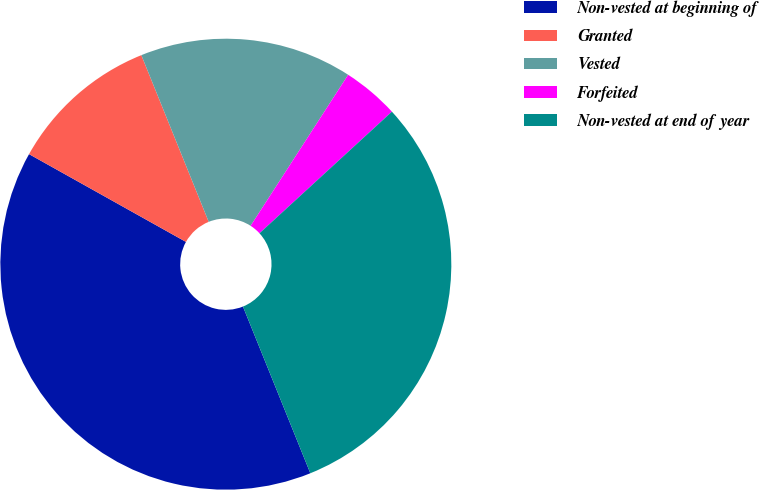<chart> <loc_0><loc_0><loc_500><loc_500><pie_chart><fcel>Non-vested at beginning of<fcel>Granted<fcel>Vested<fcel>Forfeited<fcel>Non-vested at end of year<nl><fcel>39.23%<fcel>10.77%<fcel>15.24%<fcel>4.05%<fcel>30.71%<nl></chart> 